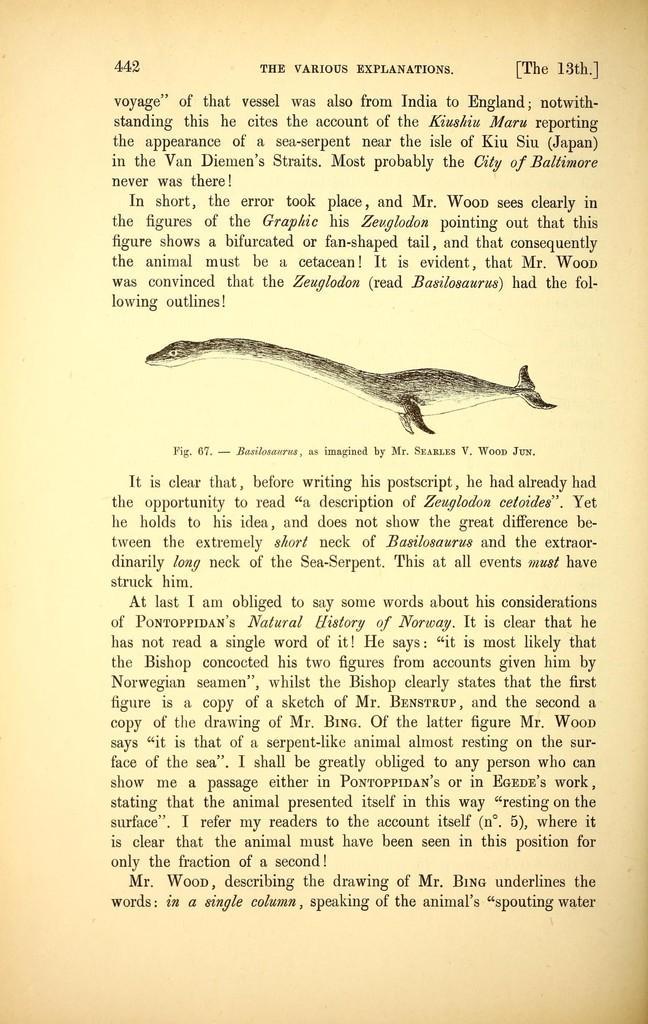Please provide a concise description of this image. This is a page and in this page we can see an animal and some text. 